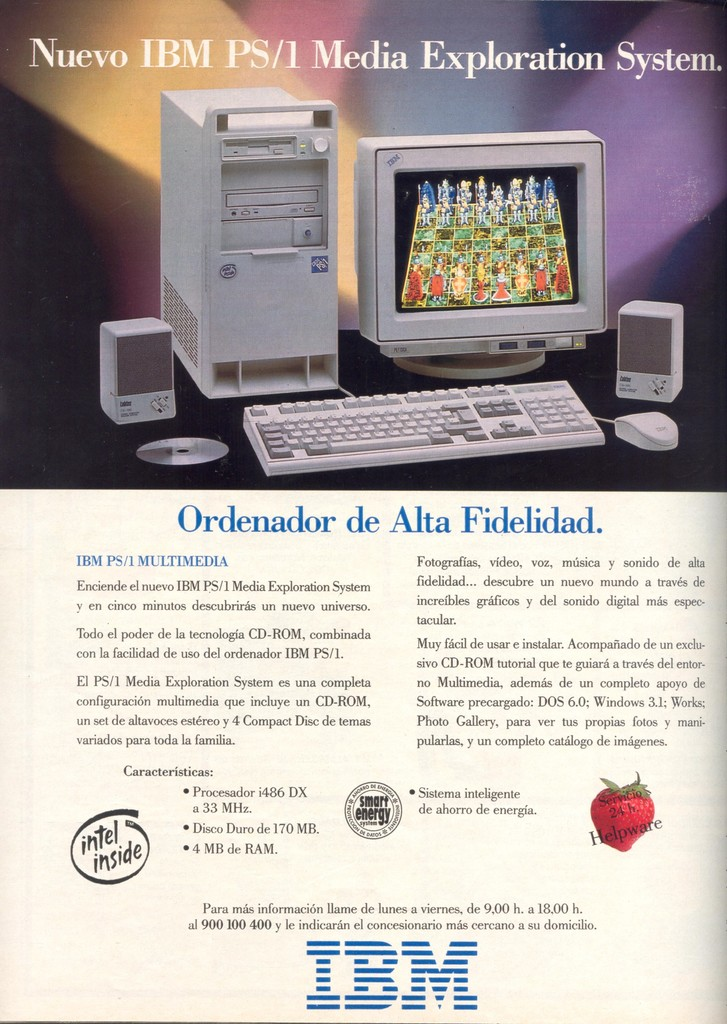Can you discuss the significance of the wax seal in the ad? The red wax seal in the advertisement, embossed with the 'IBM' logo, holds significant symbolic value. Traditionally, wax seals are used to certify authenticity and seal important documents, conveying a sense of security and trustworthiness. In the context of this ad, the seal acts as a metaphor for IBM's commitment to quality and reliability in their products. It reassures potential customers that the PS/1 Media Exploration System is a trustworthy and high-quality choice for their multimedia needs. 